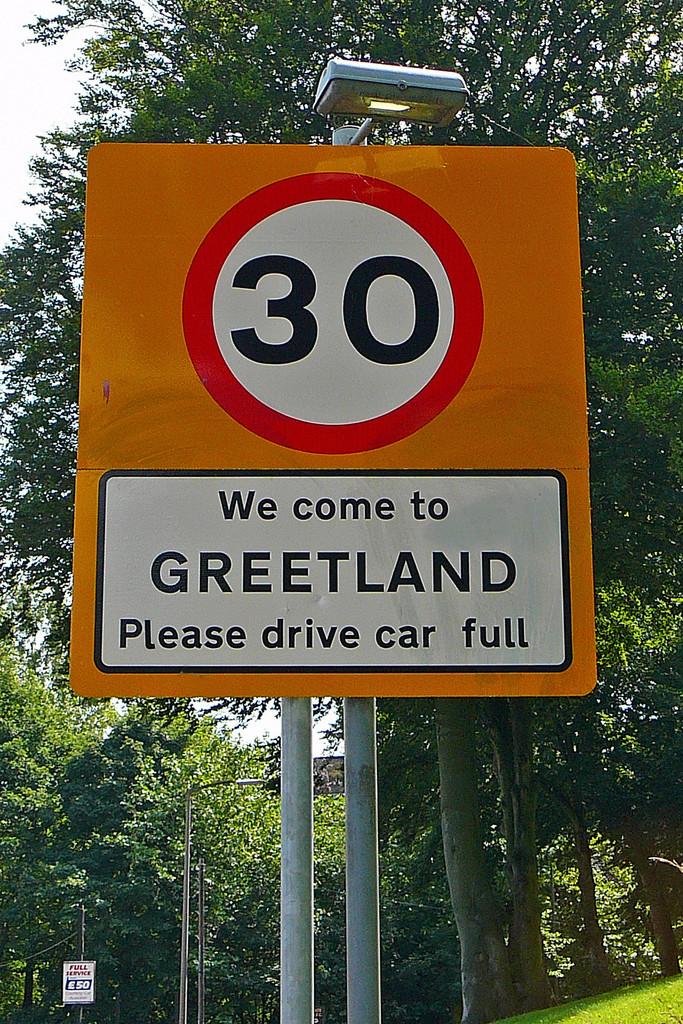What is the name of city on the sign?
Offer a very short reply. Greetland. How do they ask you to drive?
Give a very brief answer. Car full. 